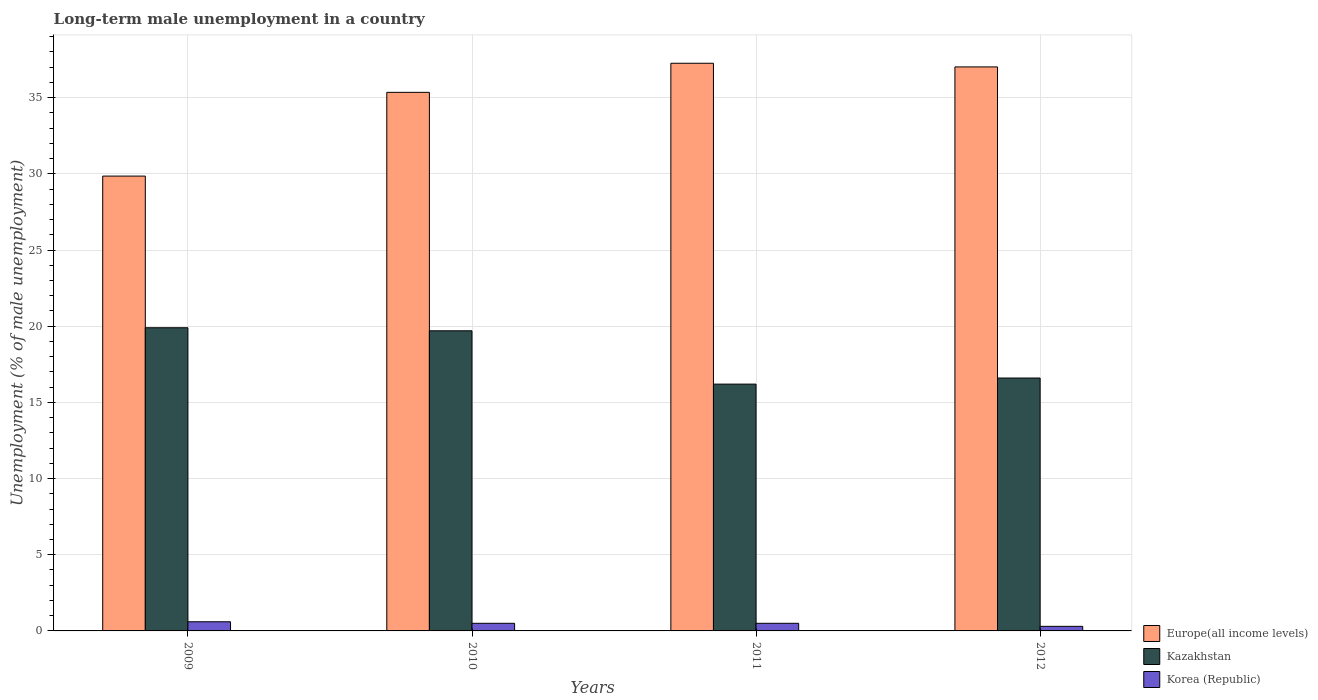How many different coloured bars are there?
Provide a succinct answer. 3. Are the number of bars on each tick of the X-axis equal?
Give a very brief answer. Yes. What is the percentage of long-term unemployed male population in Korea (Republic) in 2011?
Give a very brief answer. 0.5. Across all years, what is the maximum percentage of long-term unemployed male population in Korea (Republic)?
Provide a succinct answer. 0.6. Across all years, what is the minimum percentage of long-term unemployed male population in Korea (Republic)?
Offer a terse response. 0.3. In which year was the percentage of long-term unemployed male population in Kazakhstan maximum?
Offer a terse response. 2009. In which year was the percentage of long-term unemployed male population in Europe(all income levels) minimum?
Give a very brief answer. 2009. What is the total percentage of long-term unemployed male population in Europe(all income levels) in the graph?
Offer a terse response. 139.49. What is the difference between the percentage of long-term unemployed male population in Korea (Republic) in 2010 and that in 2012?
Keep it short and to the point. 0.2. What is the difference between the percentage of long-term unemployed male population in Europe(all income levels) in 2010 and the percentage of long-term unemployed male population in Kazakhstan in 2009?
Your response must be concise. 15.45. What is the average percentage of long-term unemployed male population in Europe(all income levels) per year?
Ensure brevity in your answer.  34.87. In the year 2011, what is the difference between the percentage of long-term unemployed male population in Kazakhstan and percentage of long-term unemployed male population in Europe(all income levels)?
Give a very brief answer. -21.06. What is the ratio of the percentage of long-term unemployed male population in Europe(all income levels) in 2011 to that in 2012?
Keep it short and to the point. 1.01. What is the difference between the highest and the second highest percentage of long-term unemployed male population in Kazakhstan?
Your answer should be compact. 0.2. What is the difference between the highest and the lowest percentage of long-term unemployed male population in Europe(all income levels)?
Provide a short and direct response. 7.41. In how many years, is the percentage of long-term unemployed male population in Kazakhstan greater than the average percentage of long-term unemployed male population in Kazakhstan taken over all years?
Your response must be concise. 2. What does the 3rd bar from the left in 2012 represents?
Give a very brief answer. Korea (Republic). What does the 3rd bar from the right in 2010 represents?
Offer a very short reply. Europe(all income levels). Is it the case that in every year, the sum of the percentage of long-term unemployed male population in Korea (Republic) and percentage of long-term unemployed male population in Europe(all income levels) is greater than the percentage of long-term unemployed male population in Kazakhstan?
Offer a terse response. Yes. How many bars are there?
Offer a very short reply. 12. Does the graph contain any zero values?
Make the answer very short. No. Where does the legend appear in the graph?
Make the answer very short. Bottom right. How are the legend labels stacked?
Your response must be concise. Vertical. What is the title of the graph?
Provide a succinct answer. Long-term male unemployment in a country. Does "Russian Federation" appear as one of the legend labels in the graph?
Your response must be concise. No. What is the label or title of the Y-axis?
Make the answer very short. Unemployment (% of male unemployment). What is the Unemployment (% of male unemployment) of Europe(all income levels) in 2009?
Your answer should be very brief. 29.85. What is the Unemployment (% of male unemployment) of Kazakhstan in 2009?
Give a very brief answer. 19.9. What is the Unemployment (% of male unemployment) in Korea (Republic) in 2009?
Provide a short and direct response. 0.6. What is the Unemployment (% of male unemployment) of Europe(all income levels) in 2010?
Give a very brief answer. 35.35. What is the Unemployment (% of male unemployment) in Kazakhstan in 2010?
Give a very brief answer. 19.7. What is the Unemployment (% of male unemployment) in Europe(all income levels) in 2011?
Offer a very short reply. 37.26. What is the Unemployment (% of male unemployment) of Kazakhstan in 2011?
Offer a very short reply. 16.2. What is the Unemployment (% of male unemployment) of Korea (Republic) in 2011?
Your answer should be very brief. 0.5. What is the Unemployment (% of male unemployment) in Europe(all income levels) in 2012?
Offer a terse response. 37.02. What is the Unemployment (% of male unemployment) in Kazakhstan in 2012?
Your answer should be very brief. 16.6. What is the Unemployment (% of male unemployment) of Korea (Republic) in 2012?
Make the answer very short. 0.3. Across all years, what is the maximum Unemployment (% of male unemployment) in Europe(all income levels)?
Ensure brevity in your answer.  37.26. Across all years, what is the maximum Unemployment (% of male unemployment) of Kazakhstan?
Ensure brevity in your answer.  19.9. Across all years, what is the maximum Unemployment (% of male unemployment) of Korea (Republic)?
Provide a short and direct response. 0.6. Across all years, what is the minimum Unemployment (% of male unemployment) of Europe(all income levels)?
Your response must be concise. 29.85. Across all years, what is the minimum Unemployment (% of male unemployment) of Kazakhstan?
Offer a very short reply. 16.2. Across all years, what is the minimum Unemployment (% of male unemployment) of Korea (Republic)?
Offer a terse response. 0.3. What is the total Unemployment (% of male unemployment) of Europe(all income levels) in the graph?
Your answer should be very brief. 139.49. What is the total Unemployment (% of male unemployment) in Kazakhstan in the graph?
Ensure brevity in your answer.  72.4. What is the total Unemployment (% of male unemployment) in Korea (Republic) in the graph?
Give a very brief answer. 1.9. What is the difference between the Unemployment (% of male unemployment) in Europe(all income levels) in 2009 and that in 2010?
Give a very brief answer. -5.5. What is the difference between the Unemployment (% of male unemployment) of Europe(all income levels) in 2009 and that in 2011?
Your answer should be very brief. -7.41. What is the difference between the Unemployment (% of male unemployment) of Europe(all income levels) in 2009 and that in 2012?
Offer a terse response. -7.17. What is the difference between the Unemployment (% of male unemployment) in Europe(all income levels) in 2010 and that in 2011?
Offer a terse response. -1.91. What is the difference between the Unemployment (% of male unemployment) in Europe(all income levels) in 2010 and that in 2012?
Keep it short and to the point. -1.67. What is the difference between the Unemployment (% of male unemployment) of Kazakhstan in 2010 and that in 2012?
Your answer should be very brief. 3.1. What is the difference between the Unemployment (% of male unemployment) of Korea (Republic) in 2010 and that in 2012?
Offer a terse response. 0.2. What is the difference between the Unemployment (% of male unemployment) in Europe(all income levels) in 2011 and that in 2012?
Offer a very short reply. 0.24. What is the difference between the Unemployment (% of male unemployment) in Kazakhstan in 2011 and that in 2012?
Your answer should be compact. -0.4. What is the difference between the Unemployment (% of male unemployment) of Korea (Republic) in 2011 and that in 2012?
Provide a short and direct response. 0.2. What is the difference between the Unemployment (% of male unemployment) in Europe(all income levels) in 2009 and the Unemployment (% of male unemployment) in Kazakhstan in 2010?
Provide a short and direct response. 10.15. What is the difference between the Unemployment (% of male unemployment) in Europe(all income levels) in 2009 and the Unemployment (% of male unemployment) in Korea (Republic) in 2010?
Make the answer very short. 29.35. What is the difference between the Unemployment (% of male unemployment) in Kazakhstan in 2009 and the Unemployment (% of male unemployment) in Korea (Republic) in 2010?
Give a very brief answer. 19.4. What is the difference between the Unemployment (% of male unemployment) in Europe(all income levels) in 2009 and the Unemployment (% of male unemployment) in Kazakhstan in 2011?
Your answer should be compact. 13.65. What is the difference between the Unemployment (% of male unemployment) of Europe(all income levels) in 2009 and the Unemployment (% of male unemployment) of Korea (Republic) in 2011?
Ensure brevity in your answer.  29.35. What is the difference between the Unemployment (% of male unemployment) of Kazakhstan in 2009 and the Unemployment (% of male unemployment) of Korea (Republic) in 2011?
Your answer should be compact. 19.4. What is the difference between the Unemployment (% of male unemployment) of Europe(all income levels) in 2009 and the Unemployment (% of male unemployment) of Kazakhstan in 2012?
Make the answer very short. 13.25. What is the difference between the Unemployment (% of male unemployment) in Europe(all income levels) in 2009 and the Unemployment (% of male unemployment) in Korea (Republic) in 2012?
Your answer should be compact. 29.55. What is the difference between the Unemployment (% of male unemployment) in Kazakhstan in 2009 and the Unemployment (% of male unemployment) in Korea (Republic) in 2012?
Make the answer very short. 19.6. What is the difference between the Unemployment (% of male unemployment) in Europe(all income levels) in 2010 and the Unemployment (% of male unemployment) in Kazakhstan in 2011?
Provide a short and direct response. 19.15. What is the difference between the Unemployment (% of male unemployment) in Europe(all income levels) in 2010 and the Unemployment (% of male unemployment) in Korea (Republic) in 2011?
Offer a terse response. 34.85. What is the difference between the Unemployment (% of male unemployment) of Europe(all income levels) in 2010 and the Unemployment (% of male unemployment) of Kazakhstan in 2012?
Make the answer very short. 18.75. What is the difference between the Unemployment (% of male unemployment) in Europe(all income levels) in 2010 and the Unemployment (% of male unemployment) in Korea (Republic) in 2012?
Your answer should be compact. 35.05. What is the difference between the Unemployment (% of male unemployment) in Europe(all income levels) in 2011 and the Unemployment (% of male unemployment) in Kazakhstan in 2012?
Your answer should be compact. 20.66. What is the difference between the Unemployment (% of male unemployment) in Europe(all income levels) in 2011 and the Unemployment (% of male unemployment) in Korea (Republic) in 2012?
Offer a very short reply. 36.96. What is the difference between the Unemployment (% of male unemployment) of Kazakhstan in 2011 and the Unemployment (% of male unemployment) of Korea (Republic) in 2012?
Offer a very short reply. 15.9. What is the average Unemployment (% of male unemployment) of Europe(all income levels) per year?
Your answer should be very brief. 34.87. What is the average Unemployment (% of male unemployment) of Korea (Republic) per year?
Your response must be concise. 0.47. In the year 2009, what is the difference between the Unemployment (% of male unemployment) in Europe(all income levels) and Unemployment (% of male unemployment) in Kazakhstan?
Your answer should be very brief. 9.95. In the year 2009, what is the difference between the Unemployment (% of male unemployment) in Europe(all income levels) and Unemployment (% of male unemployment) in Korea (Republic)?
Ensure brevity in your answer.  29.25. In the year 2009, what is the difference between the Unemployment (% of male unemployment) of Kazakhstan and Unemployment (% of male unemployment) of Korea (Republic)?
Keep it short and to the point. 19.3. In the year 2010, what is the difference between the Unemployment (% of male unemployment) in Europe(all income levels) and Unemployment (% of male unemployment) in Kazakhstan?
Your answer should be compact. 15.65. In the year 2010, what is the difference between the Unemployment (% of male unemployment) of Europe(all income levels) and Unemployment (% of male unemployment) of Korea (Republic)?
Ensure brevity in your answer.  34.85. In the year 2011, what is the difference between the Unemployment (% of male unemployment) in Europe(all income levels) and Unemployment (% of male unemployment) in Kazakhstan?
Your answer should be compact. 21.06. In the year 2011, what is the difference between the Unemployment (% of male unemployment) in Europe(all income levels) and Unemployment (% of male unemployment) in Korea (Republic)?
Provide a short and direct response. 36.76. In the year 2011, what is the difference between the Unemployment (% of male unemployment) of Kazakhstan and Unemployment (% of male unemployment) of Korea (Republic)?
Offer a terse response. 15.7. In the year 2012, what is the difference between the Unemployment (% of male unemployment) in Europe(all income levels) and Unemployment (% of male unemployment) in Kazakhstan?
Keep it short and to the point. 20.42. In the year 2012, what is the difference between the Unemployment (% of male unemployment) in Europe(all income levels) and Unemployment (% of male unemployment) in Korea (Republic)?
Your response must be concise. 36.72. In the year 2012, what is the difference between the Unemployment (% of male unemployment) of Kazakhstan and Unemployment (% of male unemployment) of Korea (Republic)?
Your answer should be very brief. 16.3. What is the ratio of the Unemployment (% of male unemployment) of Europe(all income levels) in 2009 to that in 2010?
Your response must be concise. 0.84. What is the ratio of the Unemployment (% of male unemployment) in Kazakhstan in 2009 to that in 2010?
Make the answer very short. 1.01. What is the ratio of the Unemployment (% of male unemployment) of Korea (Republic) in 2009 to that in 2010?
Provide a short and direct response. 1.2. What is the ratio of the Unemployment (% of male unemployment) in Europe(all income levels) in 2009 to that in 2011?
Provide a short and direct response. 0.8. What is the ratio of the Unemployment (% of male unemployment) in Kazakhstan in 2009 to that in 2011?
Give a very brief answer. 1.23. What is the ratio of the Unemployment (% of male unemployment) of Korea (Republic) in 2009 to that in 2011?
Provide a succinct answer. 1.2. What is the ratio of the Unemployment (% of male unemployment) in Europe(all income levels) in 2009 to that in 2012?
Provide a succinct answer. 0.81. What is the ratio of the Unemployment (% of male unemployment) in Kazakhstan in 2009 to that in 2012?
Offer a very short reply. 1.2. What is the ratio of the Unemployment (% of male unemployment) in Korea (Republic) in 2009 to that in 2012?
Offer a very short reply. 2. What is the ratio of the Unemployment (% of male unemployment) in Europe(all income levels) in 2010 to that in 2011?
Offer a very short reply. 0.95. What is the ratio of the Unemployment (% of male unemployment) in Kazakhstan in 2010 to that in 2011?
Ensure brevity in your answer.  1.22. What is the ratio of the Unemployment (% of male unemployment) in Europe(all income levels) in 2010 to that in 2012?
Provide a short and direct response. 0.95. What is the ratio of the Unemployment (% of male unemployment) in Kazakhstan in 2010 to that in 2012?
Offer a very short reply. 1.19. What is the ratio of the Unemployment (% of male unemployment) in Korea (Republic) in 2010 to that in 2012?
Your answer should be compact. 1.67. What is the ratio of the Unemployment (% of male unemployment) in Kazakhstan in 2011 to that in 2012?
Your answer should be compact. 0.98. What is the difference between the highest and the second highest Unemployment (% of male unemployment) of Europe(all income levels)?
Provide a succinct answer. 0.24. What is the difference between the highest and the second highest Unemployment (% of male unemployment) of Kazakhstan?
Your answer should be very brief. 0.2. What is the difference between the highest and the lowest Unemployment (% of male unemployment) in Europe(all income levels)?
Your answer should be very brief. 7.41. 